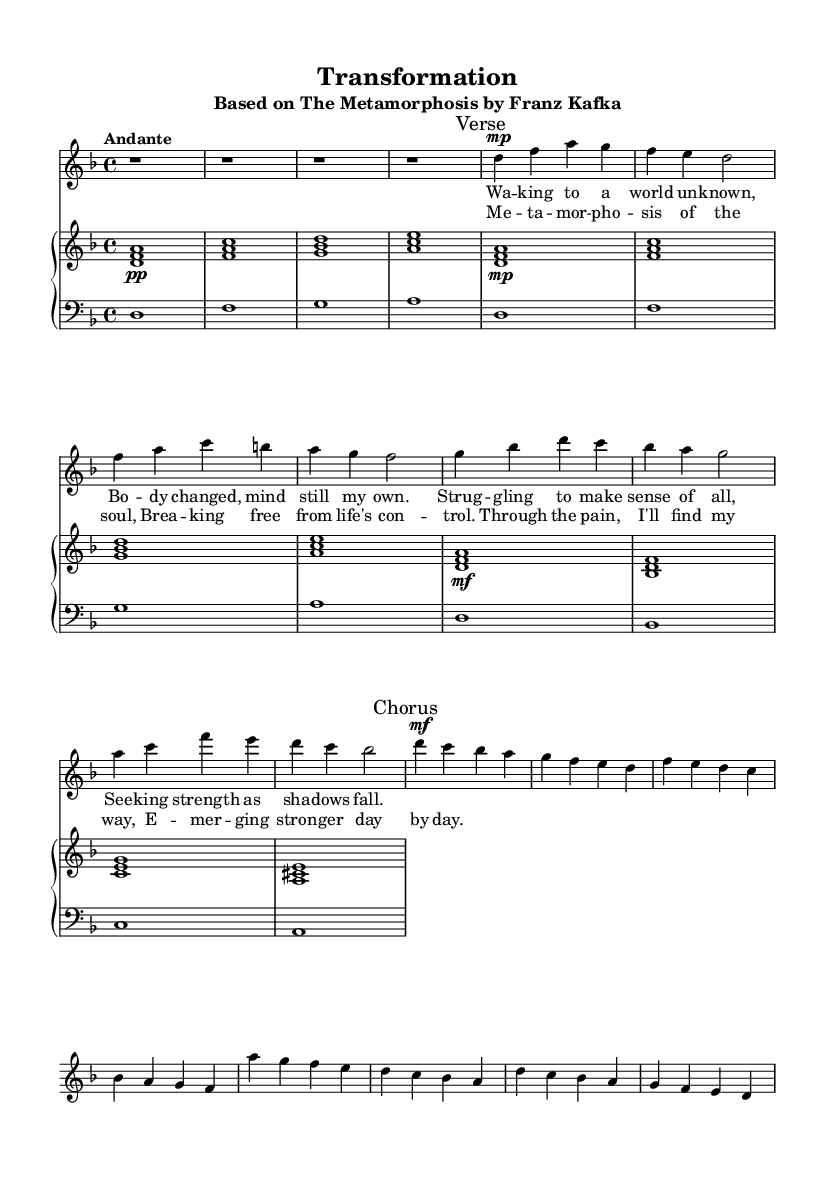What is the key signature of this music? The key signature is indicated at the beginning of the sheet music, showing two flats, which typically corresponds to the key of D minor.
Answer: D minor What is the time signature of the piece? The time signature appears right after the key signature at the beginning, indicated as "4/4", which means there are four beats in each measure.
Answer: 4/4 What is the tempo marking for this piece? The tempo marking is found at the beginning of the score, written as "Andante", indicating a moderate pace.
Answer: Andante How many sections are there in the song? By analyzing the structure of the music, we can see there is an introduction, one verse, and one chorus section. This indicates a total of three main parts.
Answer: Three What is the dynamic marking of the chorus? The dynamics for the chorus are specified as "mf", which stands for mezzo-forte, indicating a moderately loud volume.
Answer: mf Identify the primary theme of the lyrics. The lyrics reveal a central theme of personal transformation and striving for strength amidst struggle, influenced by the concept of metamorphosis.
Answer: Personal transformation What literary work is this opera based on? The title of the piece indicates it is based on "The Metamorphosis" by Franz Kafka, highlighting the connection to themes of self-discovery.
Answer: The Metamorphosis 